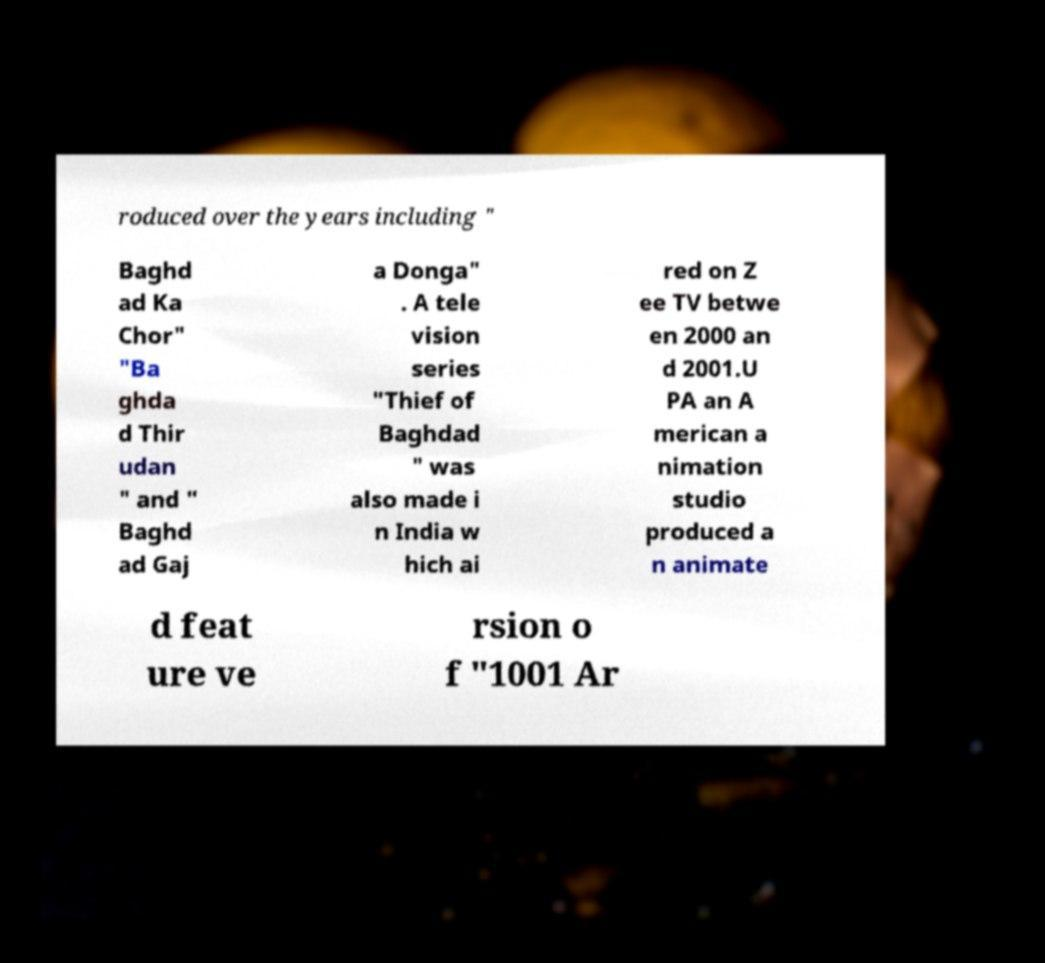Please read and relay the text visible in this image. What does it say? roduced over the years including " Baghd ad Ka Chor" "Ba ghda d Thir udan " and " Baghd ad Gaj a Donga" . A tele vision series "Thief of Baghdad " was also made i n India w hich ai red on Z ee TV betwe en 2000 an d 2001.U PA an A merican a nimation studio produced a n animate d feat ure ve rsion o f "1001 Ar 